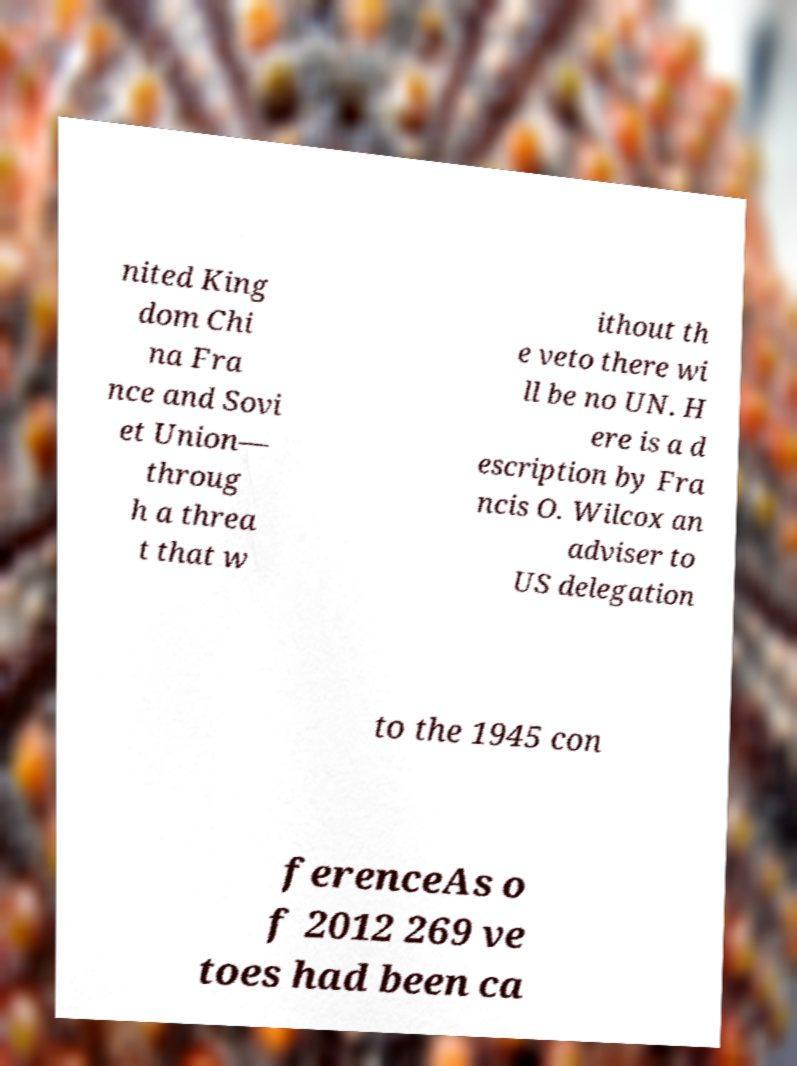For documentation purposes, I need the text within this image transcribed. Could you provide that? nited King dom Chi na Fra nce and Sovi et Union— throug h a threa t that w ithout th e veto there wi ll be no UN. H ere is a d escription by Fra ncis O. Wilcox an adviser to US delegation to the 1945 con ferenceAs o f 2012 269 ve toes had been ca 